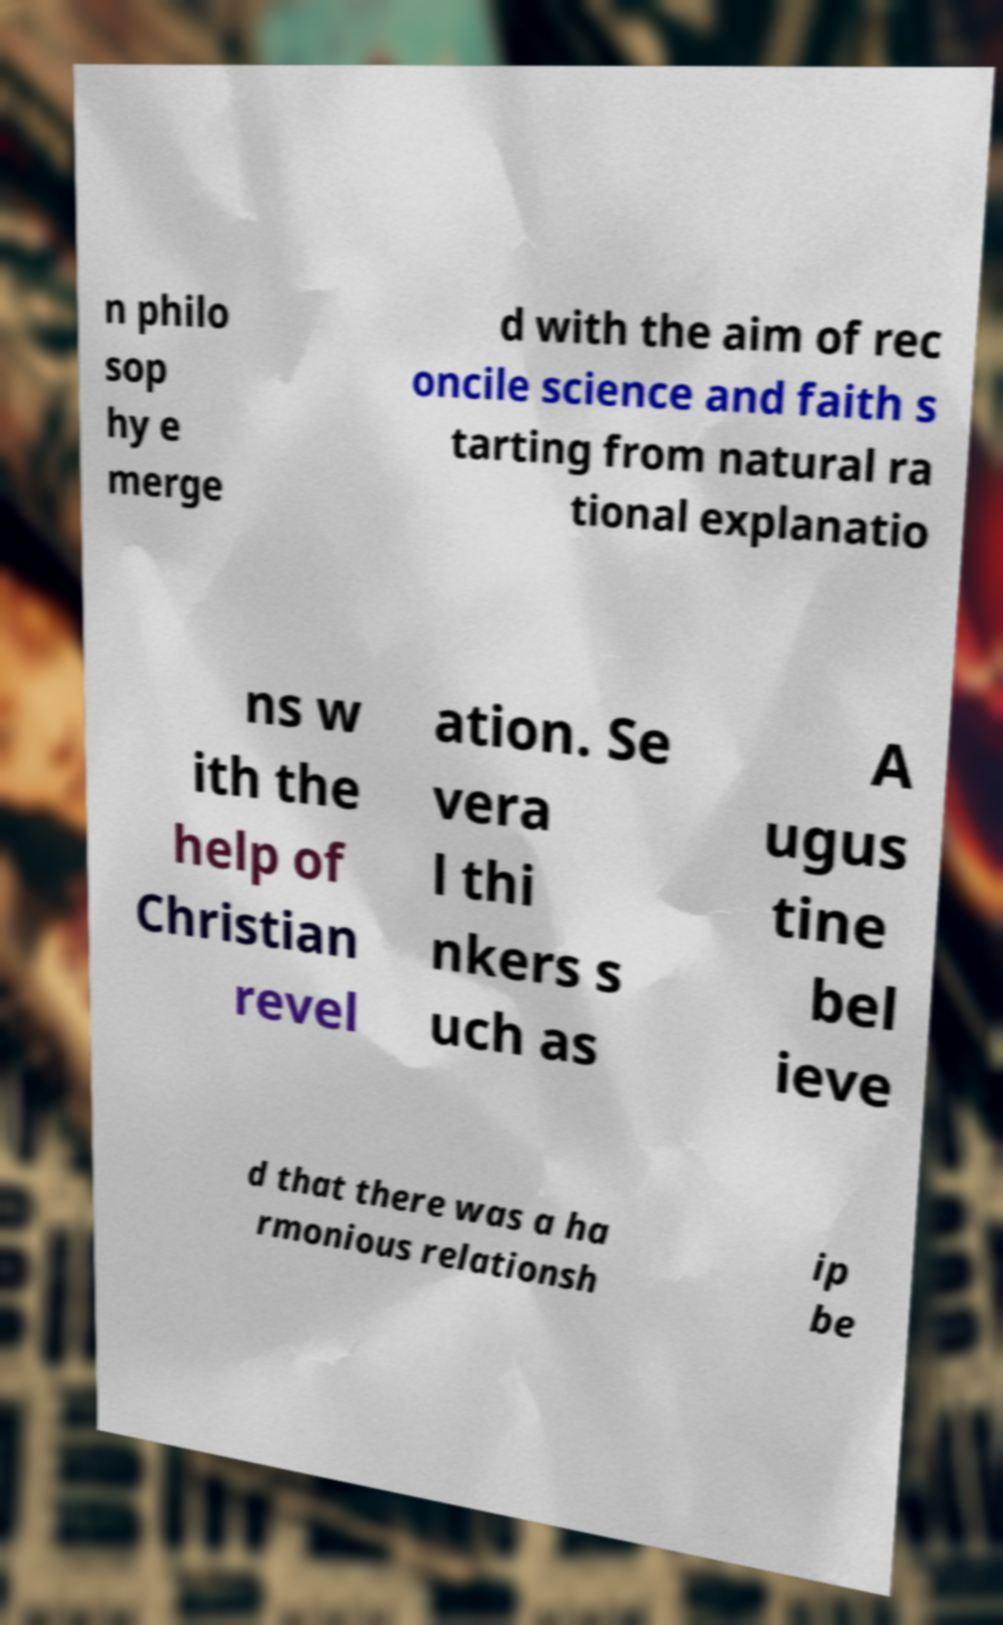For documentation purposes, I need the text within this image transcribed. Could you provide that? n philo sop hy e merge d with the aim of rec oncile science and faith s tarting from natural ra tional explanatio ns w ith the help of Christian revel ation. Se vera l thi nkers s uch as A ugus tine bel ieve d that there was a ha rmonious relationsh ip be 